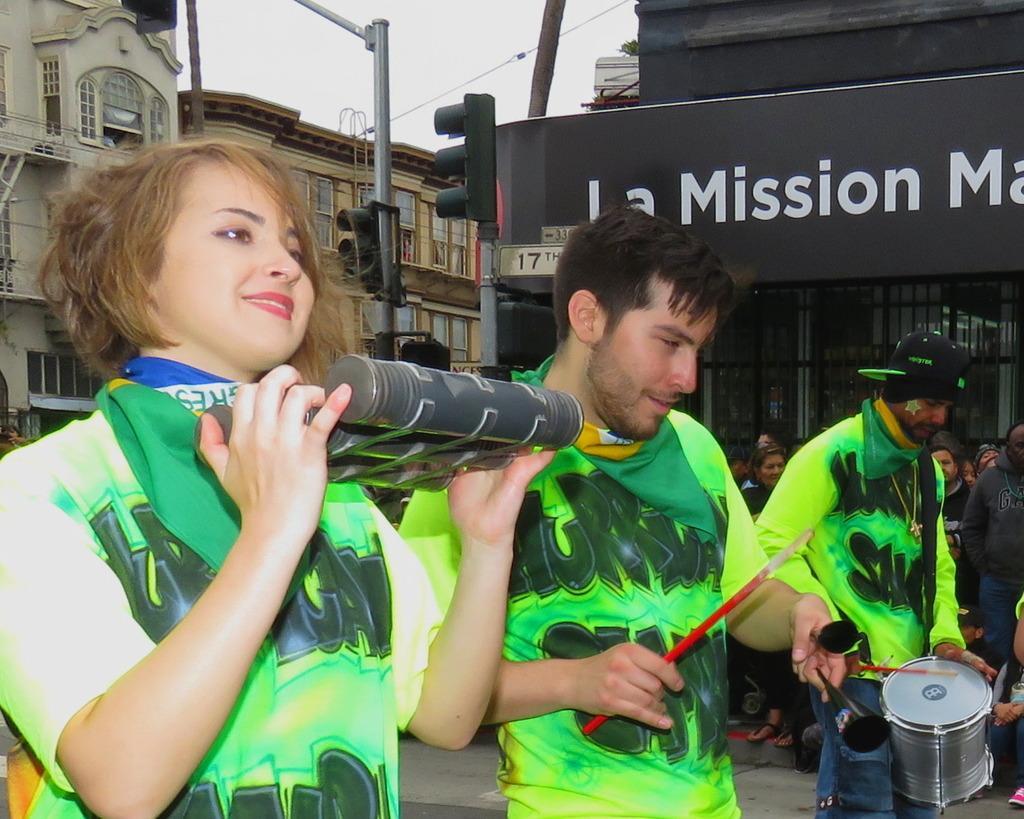In one or two sentences, can you explain what this image depicts? In the image there is a woman and two men playing playing drum and other music instruments. It seems to be on a road. Behind them there is traffic light and storefront. The background there is building and above its sky. 